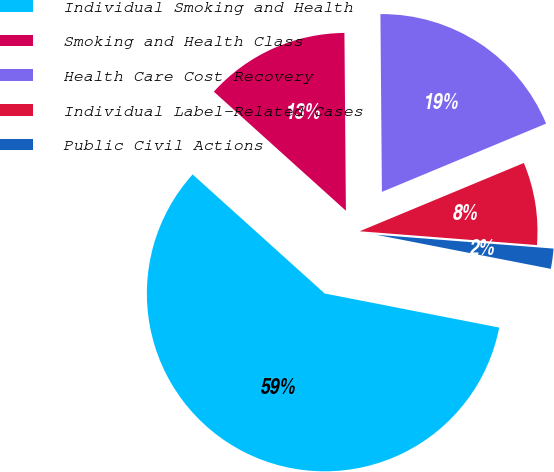<chart> <loc_0><loc_0><loc_500><loc_500><pie_chart><fcel>Individual Smoking and Health<fcel>Smoking and Health Class<fcel>Health Care Cost Recovery<fcel>Individual Label-Related Cases<fcel>Public Civil Actions<nl><fcel>58.61%<fcel>13.19%<fcel>18.86%<fcel>7.51%<fcel>1.83%<nl></chart> 